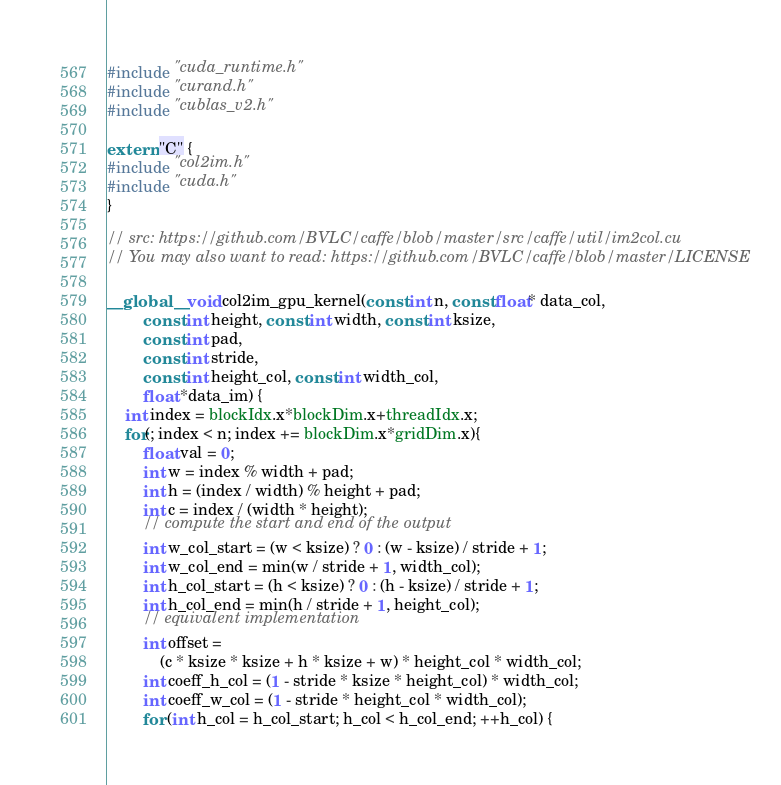<code> <loc_0><loc_0><loc_500><loc_500><_Cuda_>#include "cuda_runtime.h"
#include "curand.h"
#include "cublas_v2.h"

extern "C" {
#include "col2im.h"
#include "cuda.h"
}

// src: https://github.com/BVLC/caffe/blob/master/src/caffe/util/im2col.cu
// You may also want to read: https://github.com/BVLC/caffe/blob/master/LICENSE

__global__ void col2im_gpu_kernel(const int n, const float* data_col,
        const int height, const int width, const int ksize,
        const int pad,
        const int stride,
        const int height_col, const int width_col,
        float *data_im) {
    int index = blockIdx.x*blockDim.x+threadIdx.x;
    for(; index < n; index += blockDim.x*gridDim.x){
        float val = 0;
        int w = index % width + pad;
        int h = (index / width) % height + pad;
        int c = index / (width * height);
        // compute the start and end of the output
        int w_col_start = (w < ksize) ? 0 : (w - ksize) / stride + 1;
        int w_col_end = min(w / stride + 1, width_col);
        int h_col_start = (h < ksize) ? 0 : (h - ksize) / stride + 1;
        int h_col_end = min(h / stride + 1, height_col);
        // equivalent implementation
        int offset =
            (c * ksize * ksize + h * ksize + w) * height_col * width_col;
        int coeff_h_col = (1 - stride * ksize * height_col) * width_col;
        int coeff_w_col = (1 - stride * height_col * width_col);
        for (int h_col = h_col_start; h_col < h_col_end; ++h_col) {</code> 